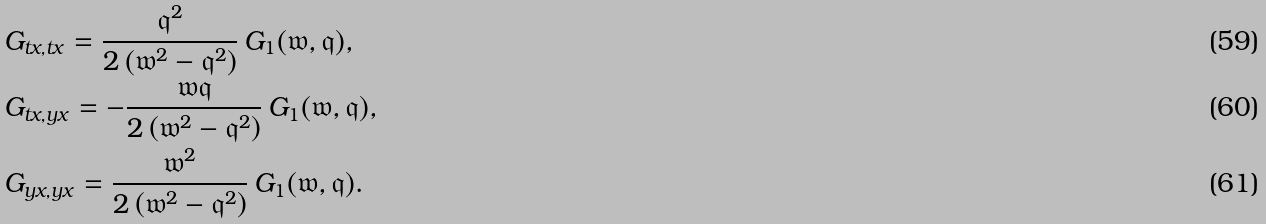Convert formula to latex. <formula><loc_0><loc_0><loc_500><loc_500>& G _ { t x , t x } = \frac { \mathfrak { q } ^ { 2 } } { 2 \left ( \mathfrak { w } ^ { 2 } - \mathfrak { q } ^ { 2 } \right ) } \, G _ { 1 } ( \mathfrak { w } , \mathfrak { q } ) , \\ & G _ { t x , y x } = - \frac { \mathfrak { w } \mathfrak { q } } { 2 \left ( \mathfrak { w } ^ { 2 } - \mathfrak { q } ^ { 2 } \right ) } \, G _ { 1 } ( \mathfrak { w } , \mathfrak { q } ) , \\ & G _ { y x , y x } = \frac { \mathfrak { w } ^ { 2 } } { 2 \left ( \mathfrak { w } ^ { 2 } - \mathfrak { q } ^ { 2 } \right ) } \, G _ { 1 } ( \mathfrak { w } , \mathfrak { q } ) .</formula> 